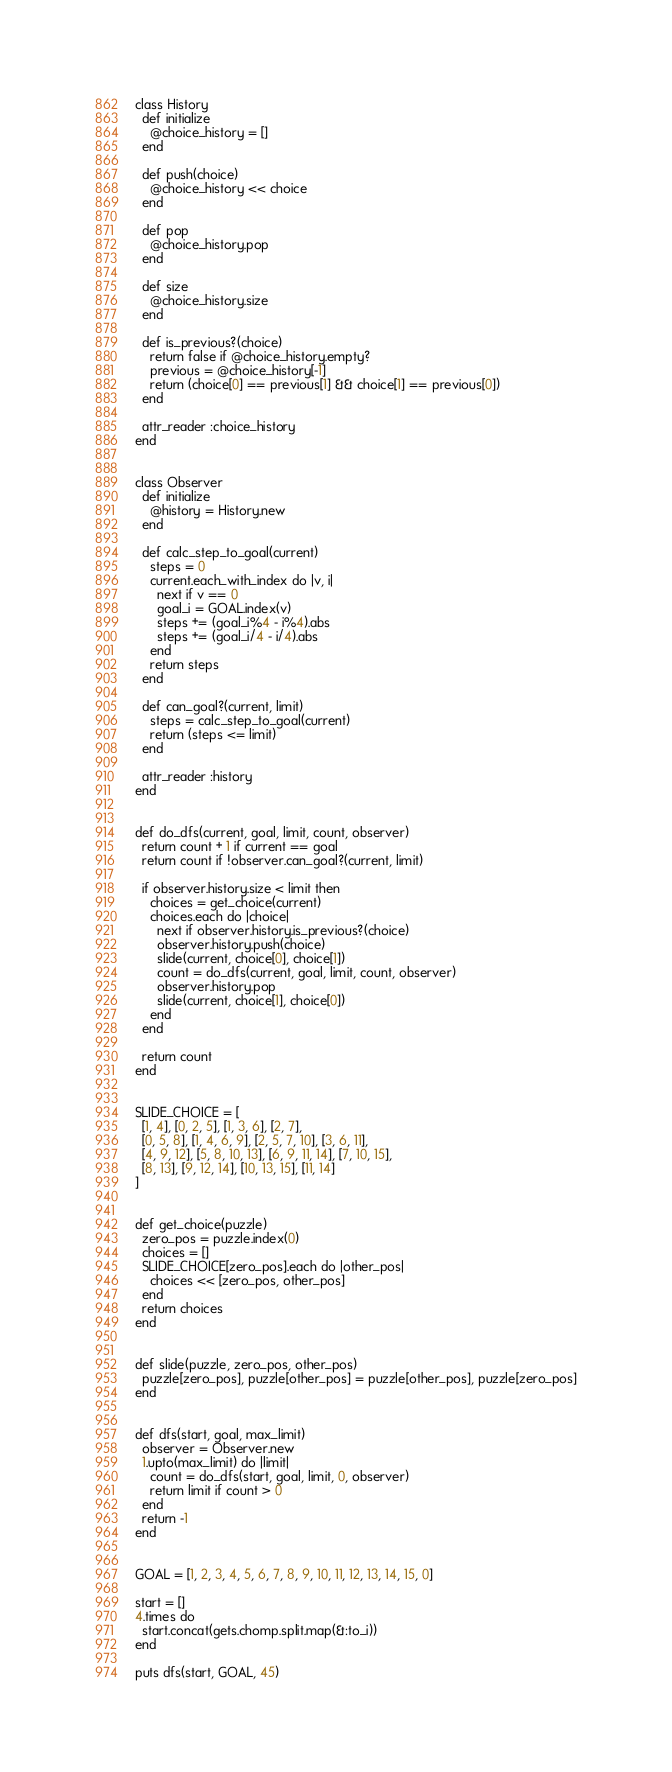<code> <loc_0><loc_0><loc_500><loc_500><_Ruby_>class History
  def initialize
    @choice_history = []
  end

  def push(choice)
    @choice_history << choice
  end

  def pop
    @choice_history.pop
  end

  def size
    @choice_history.size
  end

  def is_previous?(choice)
    return false if @choice_history.empty?
    previous = @choice_history[-1]
    return (choice[0] == previous[1] && choice[1] == previous[0])
  end

  attr_reader :choice_history
end


class Observer
  def initialize
    @history = History.new
  end

  def calc_step_to_goal(current)
    steps = 0
    current.each_with_index do |v, i|
      next if v == 0
      goal_i = GOAL.index(v)
      steps += (goal_i%4 - i%4).abs
      steps += (goal_i/4 - i/4).abs
    end
    return steps
  end

  def can_goal?(current, limit)
    steps = calc_step_to_goal(current)
    return (steps <= limit)
  end

  attr_reader :history
end


def do_dfs(current, goal, limit, count, observer)
  return count + 1 if current == goal
  return count if !observer.can_goal?(current, limit)

  if observer.history.size < limit then
    choices = get_choice(current)
    choices.each do |choice|
      next if observer.history.is_previous?(choice)
      observer.history.push(choice)
      slide(current, choice[0], choice[1])
      count = do_dfs(current, goal, limit, count, observer)
      observer.history.pop
      slide(current, choice[1], choice[0])
    end
  end

  return count
end


SLIDE_CHOICE = [
  [1, 4], [0, 2, 5], [1, 3, 6], [2, 7],
  [0, 5, 8], [1, 4, 6, 9], [2, 5, 7, 10], [3, 6, 11],
  [4, 9, 12], [5, 8, 10, 13], [6, 9, 11, 14], [7, 10, 15],
  [8, 13], [9, 12, 14], [10, 13, 15], [11, 14]
]


def get_choice(puzzle)
  zero_pos = puzzle.index(0)
  choices = []
  SLIDE_CHOICE[zero_pos].each do |other_pos|
    choices << [zero_pos, other_pos]
  end
  return choices
end


def slide(puzzle, zero_pos, other_pos)
  puzzle[zero_pos], puzzle[other_pos] = puzzle[other_pos], puzzle[zero_pos]
end


def dfs(start, goal, max_limit)
  observer = Observer.new
  1.upto(max_limit) do |limit|
    count = do_dfs(start, goal, limit, 0, observer)
    return limit if count > 0
  end
  return -1
end


GOAL = [1, 2, 3, 4, 5, 6, 7, 8, 9, 10, 11, 12, 13, 14, 15, 0]

start = []
4.times do 
  start.concat(gets.chomp.split.map(&:to_i))
end

puts dfs(start, GOAL, 45)</code> 